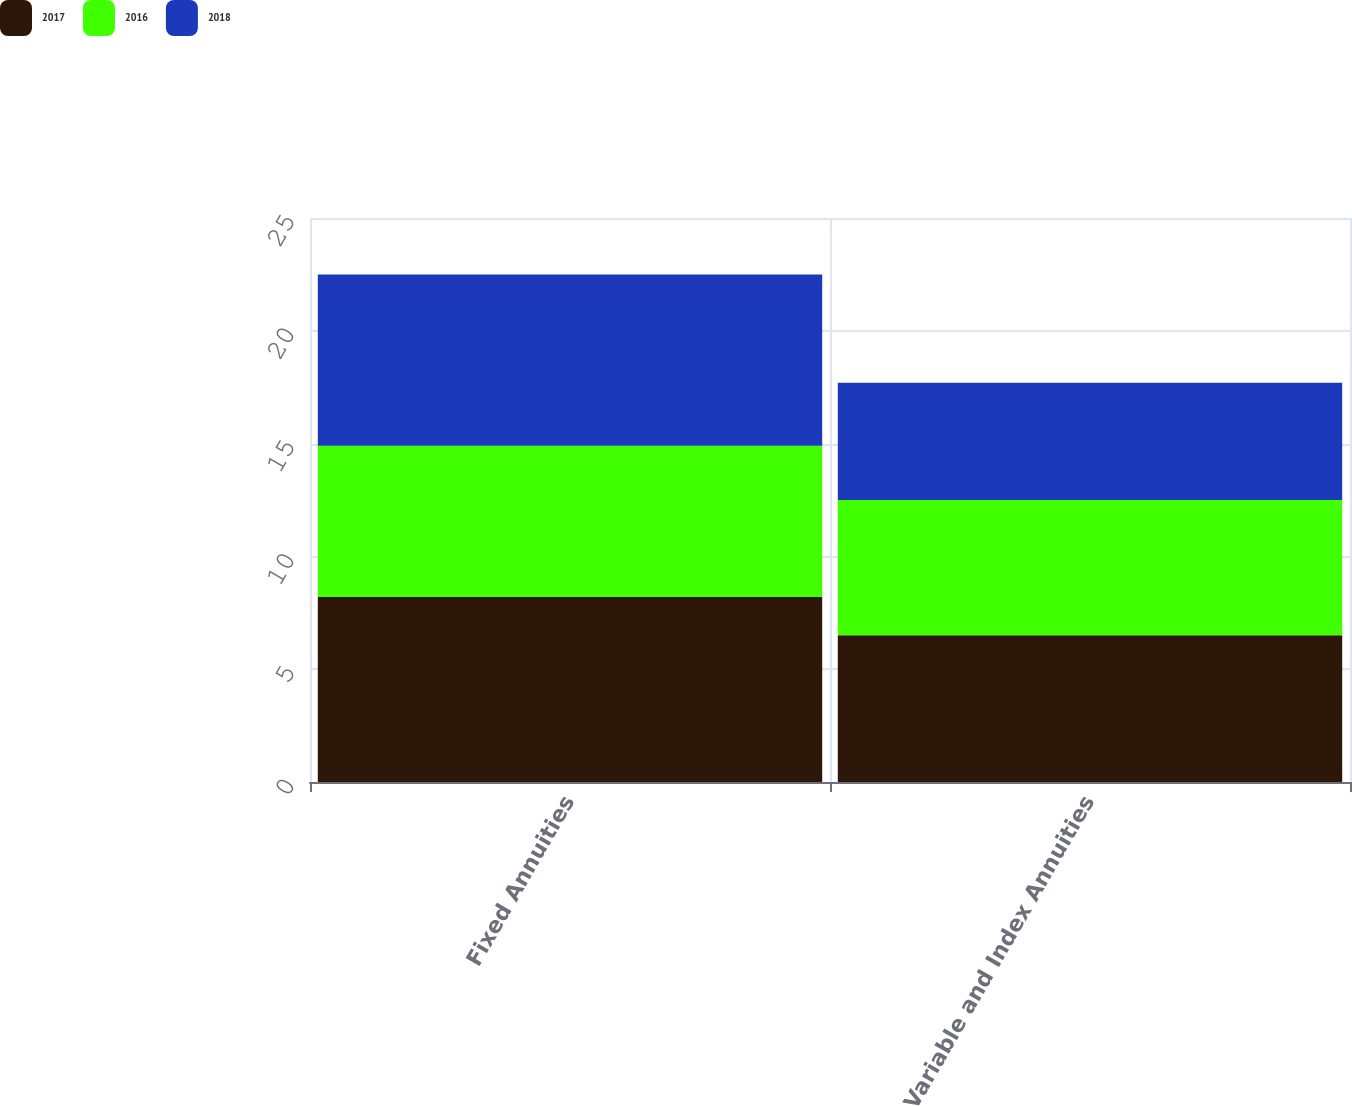Convert chart to OTSL. <chart><loc_0><loc_0><loc_500><loc_500><stacked_bar_chart><ecel><fcel>Fixed Annuities<fcel>Variable and Index Annuities<nl><fcel>2017<fcel>8.2<fcel>6.5<nl><fcel>2016<fcel>6.7<fcel>6<nl><fcel>2018<fcel>7.6<fcel>5.2<nl></chart> 